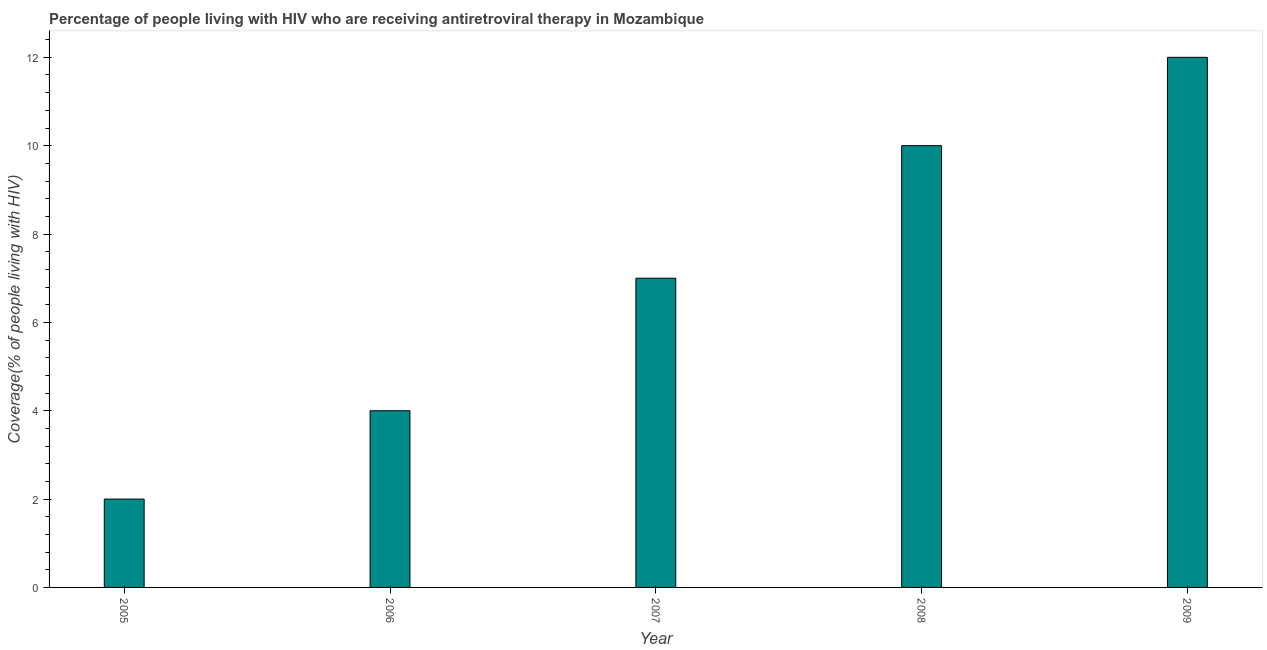Does the graph contain any zero values?
Offer a terse response. No. Does the graph contain grids?
Your answer should be compact. No. What is the title of the graph?
Offer a very short reply. Percentage of people living with HIV who are receiving antiretroviral therapy in Mozambique. What is the label or title of the Y-axis?
Your answer should be very brief. Coverage(% of people living with HIV). Across all years, what is the maximum antiretroviral therapy coverage?
Offer a very short reply. 12. In which year was the antiretroviral therapy coverage minimum?
Provide a short and direct response. 2005. What is the difference between the antiretroviral therapy coverage in 2008 and 2009?
Provide a short and direct response. -2. What is the median antiretroviral therapy coverage?
Keep it short and to the point. 7. In how many years, is the antiretroviral therapy coverage greater than 6.8 %?
Ensure brevity in your answer.  3. What is the ratio of the antiretroviral therapy coverage in 2006 to that in 2009?
Your answer should be very brief. 0.33. Is the antiretroviral therapy coverage in 2006 less than that in 2008?
Keep it short and to the point. Yes. What is the difference between the highest and the lowest antiretroviral therapy coverage?
Give a very brief answer. 10. How many bars are there?
Your response must be concise. 5. How many years are there in the graph?
Your response must be concise. 5. What is the Coverage(% of people living with HIV) of 2006?
Offer a very short reply. 4. What is the difference between the Coverage(% of people living with HIV) in 2005 and 2006?
Give a very brief answer. -2. What is the difference between the Coverage(% of people living with HIV) in 2005 and 2007?
Give a very brief answer. -5. What is the difference between the Coverage(% of people living with HIV) in 2005 and 2008?
Your answer should be very brief. -8. What is the difference between the Coverage(% of people living with HIV) in 2005 and 2009?
Your answer should be very brief. -10. What is the difference between the Coverage(% of people living with HIV) in 2006 and 2008?
Keep it short and to the point. -6. What is the difference between the Coverage(% of people living with HIV) in 2006 and 2009?
Provide a short and direct response. -8. What is the difference between the Coverage(% of people living with HIV) in 2007 and 2008?
Your answer should be compact. -3. What is the difference between the Coverage(% of people living with HIV) in 2007 and 2009?
Make the answer very short. -5. What is the difference between the Coverage(% of people living with HIV) in 2008 and 2009?
Keep it short and to the point. -2. What is the ratio of the Coverage(% of people living with HIV) in 2005 to that in 2007?
Provide a succinct answer. 0.29. What is the ratio of the Coverage(% of people living with HIV) in 2005 to that in 2008?
Your response must be concise. 0.2. What is the ratio of the Coverage(% of people living with HIV) in 2005 to that in 2009?
Provide a short and direct response. 0.17. What is the ratio of the Coverage(% of people living with HIV) in 2006 to that in 2007?
Your answer should be very brief. 0.57. What is the ratio of the Coverage(% of people living with HIV) in 2006 to that in 2008?
Keep it short and to the point. 0.4. What is the ratio of the Coverage(% of people living with HIV) in 2006 to that in 2009?
Ensure brevity in your answer.  0.33. What is the ratio of the Coverage(% of people living with HIV) in 2007 to that in 2008?
Keep it short and to the point. 0.7. What is the ratio of the Coverage(% of people living with HIV) in 2007 to that in 2009?
Provide a short and direct response. 0.58. What is the ratio of the Coverage(% of people living with HIV) in 2008 to that in 2009?
Make the answer very short. 0.83. 